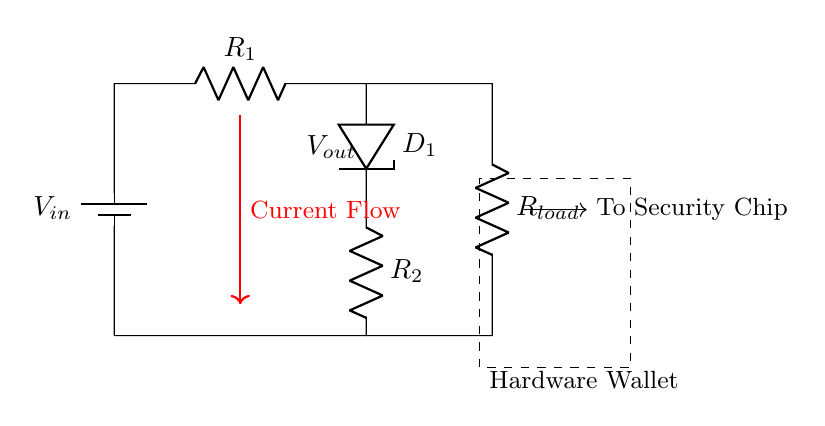what is the input voltage in this circuit? The input voltage, denoted as \( V_{in} \), is provided by the battery in the circuit diagram. It is located at the top left of the circuit where the battery symbol is shown.
Answer: \( V_{in} \) what do \( R_1 \) and \( R_2 \) form in the circuit? \( R_1 \) and \( R_2 \) form a voltage divider, which is used to reduce the input voltage to a lower output voltage at the junction where they are connected. This is a hallmark feature of voltage divider configurations.
Answer: Voltage divider what is the purpose of the Zener diode in the circuit? The Zener diode \( D_1 \) is used for voltage regulation. It maintains a stable output voltage across it, ensuring that the voltage supplied to the load remains constant even if the input voltage varies.
Answer: Regulation what is the load connected to the circuit? The load in the circuit is represented as \( R_{load} \), which is the resistor connected after the Zener diode and is used to power the security chip of the hardware wallet. This resistor signifies the part of the circuit that consumes power.
Answer: \( R_{load} \) how many resistors are in this circuit? The circuit contains two resistors: \( R_1 \) and \( R_2 \), along with the load resistor \( R_{load} \) which is also a resistor, making a total of three resistors in the circuit.
Answer: Three what voltage appears across the Zener diode \( D_1 \)? The voltage across the Zener diode \( D_1 \) is the output voltage denoted as \( V_{out} \), which is determined by the characteristics of the diode and the resistors in the divider network. This is the voltage delivered to the security chip.
Answer: \( V_{out} \) what is the direction of current flow in the circuit? The current flow is indicated by the arrow labeled "Current Flow", which shows the direction of current from the battery through \( R_1 \), \( D_1 \), and \( R_2 \) to the load. This direction denotes a typical current path in a voltage divider setup.
Answer: Downwards 